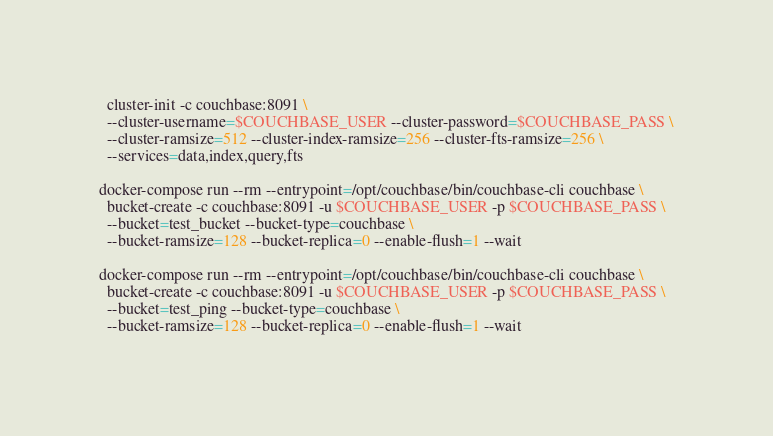<code> <loc_0><loc_0><loc_500><loc_500><_Bash_>  cluster-init -c couchbase:8091 \
  --cluster-username=$COUCHBASE_USER --cluster-password=$COUCHBASE_PASS \
  --cluster-ramsize=512 --cluster-index-ramsize=256 --cluster-fts-ramsize=256 \
  --services=data,index,query,fts

docker-compose run --rm --entrypoint=/opt/couchbase/bin/couchbase-cli couchbase \
  bucket-create -c couchbase:8091 -u $COUCHBASE_USER -p $COUCHBASE_PASS \
  --bucket=test_bucket --bucket-type=couchbase \
  --bucket-ramsize=128 --bucket-replica=0 --enable-flush=1 --wait

docker-compose run --rm --entrypoint=/opt/couchbase/bin/couchbase-cli couchbase \
  bucket-create -c couchbase:8091 -u $COUCHBASE_USER -p $COUCHBASE_PASS \
  --bucket=test_ping --bucket-type=couchbase \
  --bucket-ramsize=128 --bucket-replica=0 --enable-flush=1 --wait
</code> 